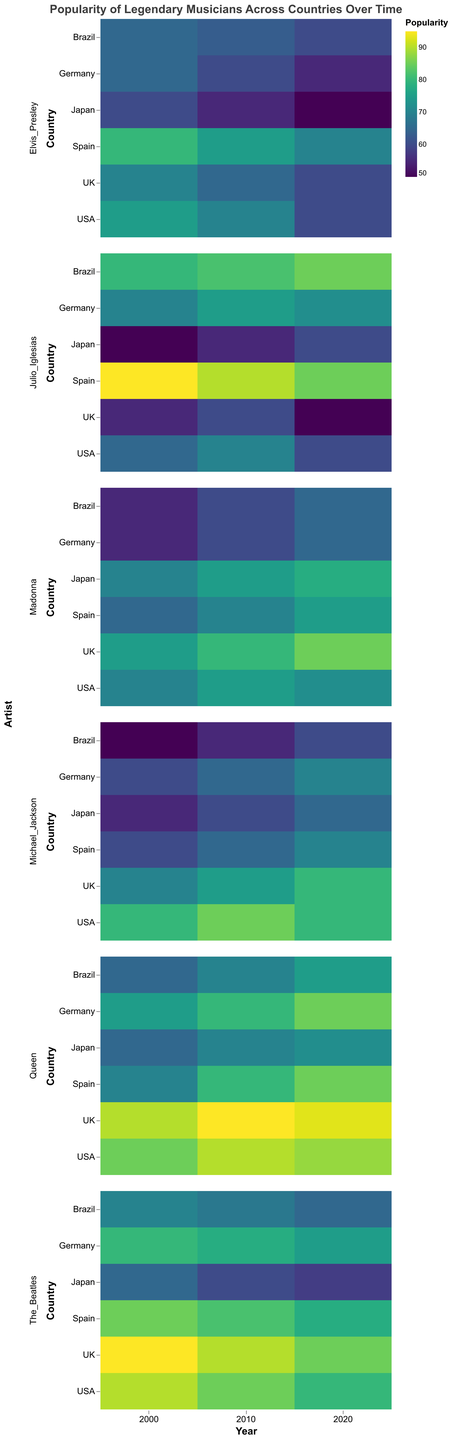What is the title of the heatmap? The title is usually found at the top of the heatmap and describes what the visual represents. In this case, the title states, "Popularity of Legendary Musicians Across Countries Over Time."
Answer: Popularity of Legendary Musicians Across Countries Over Time Which country had the highest popularity score for Julio Iglesias in 2000? Locate the row corresponding to "Julio Iglesias" and the column for the year 2000. Then, find the highest value in that row for that year. According to the data, Spain had the highest score of 95.
Answer: Spain How has the popularity of The Beatles in the UK changed from 2000 to 2020? Locate the rows corresponding to "UK" and the columns for the years 2000, 2010, and 2020 in the row for "The Beatles." The scores are 95 (2000), 90 (2010), and 85 (2020), showing a downward trend.
Answer: Decreased Compare Madonna's popularity in Germany in 2000 and 2020. Which year was she more popular? Locate the Germany row and the years 2000 and 2020 in the row for "Madonna." The values are 55 (2000) and 65 (2020). Higher value indicates more popularity.
Answer: 2020 Which artist had the highest popularity score in Japan in 2020? Find the Japan row for the year 2020 and compare the popularity scores for all artists. Madonna has the highest score with 78.
Answer: Madonna What is the average popularity of Michael Jackson in Brazil across all available years? Extract Michael Jackson's popularity scores for Brazil for the years 2000, 2010, and 2020: 50, 55, and 60. Average = (50+55+60)/3 = 55.
Answer: 55 Which artist experienced the most significant increase in popularity in Spain between 2000 and 2020? Calculate the difference in popularity scores between 2000 and 2020 for each artist in Spain. Julio Iglesias dropped from 95 to 85 (Δ=-10), The Beatles from 85 to 78 (Δ=-7), Elvis Presley from 80 to 70 (Δ=-10), Michael Jackson from 60 to 70 (Δ=+10), Madonna from 65 to 75 (Δ=+10), Queen from 70 to 85 (Δ=+15). Queen had the highest increase of 15.
Answer: Queen What is the color scheme used in the heatmap to represent popularity scores? The color scheme used in the heatmap, which is responsible for varying colors according to popularity scores, is "viridis."
Answer: viridis Which country has the most balanced popularity scores for all artists in the year 2010? For each country in 2010, calculate the range (max-min) of the popularity scores. The smallest range indicates the most balanced scores.
- USA: max=90 (Queen), min=70 (Elvis Presley), range = 20
- Spain: max=90 (Julio Iglesias), min=65 (Michael Jackson), range = 25
- UK: max=95 (Queen), min=60 (Elvis Presley), range = 35
- Brazil: max=82 (Julio Iglesias), min=55 (Michael Jackson), range = 27
- Japan: max=75 (Madonna), min=55 (Elvis Presley), range = 20
- Germany: max=78 (The Beatles), min=60 (Elvis Presley), range = 18. Therefore, Germany is the most balanced.
Answer: Germany Which artist had the lowest popularity score in any country or year? Identify the lowest value in the heatmap across all artists and years. Elvis Presley in Japan in 2020 scored the lowest with 50.
Answer: Elvis Presley in Japan in 2020 